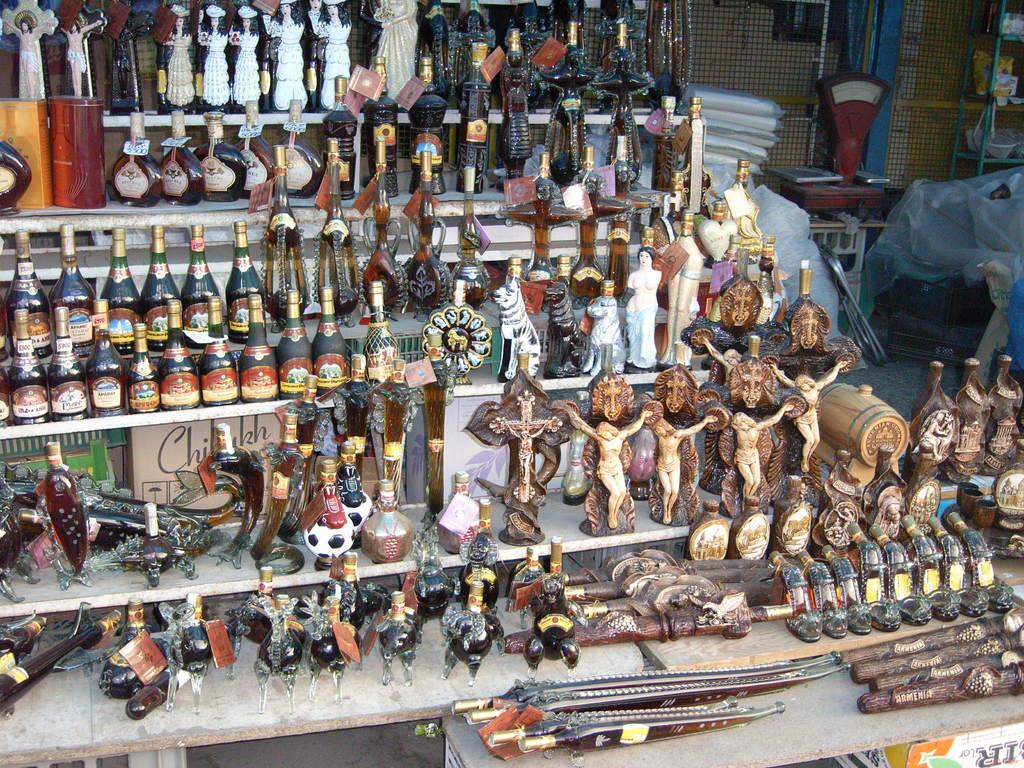Can you describe this image briefly? In the picture there are different dolls,bottles and some sculptures are kept in the display and behind these items there is a mesh and in front of the mesh there are some unwanted objects are kept. 